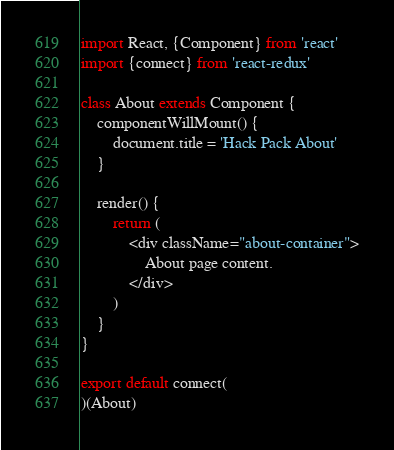Convert code to text. <code><loc_0><loc_0><loc_500><loc_500><_JavaScript_>import React, {Component} from 'react'
import {connect} from 'react-redux'

class About extends Component {
    componentWillMount() {
        document.title = 'Hack Pack About'
    }

    render() {
        return (
            <div className="about-container">
                About page content.
            </div>
        )
    }
}

export default connect(
)(About)
</code> 